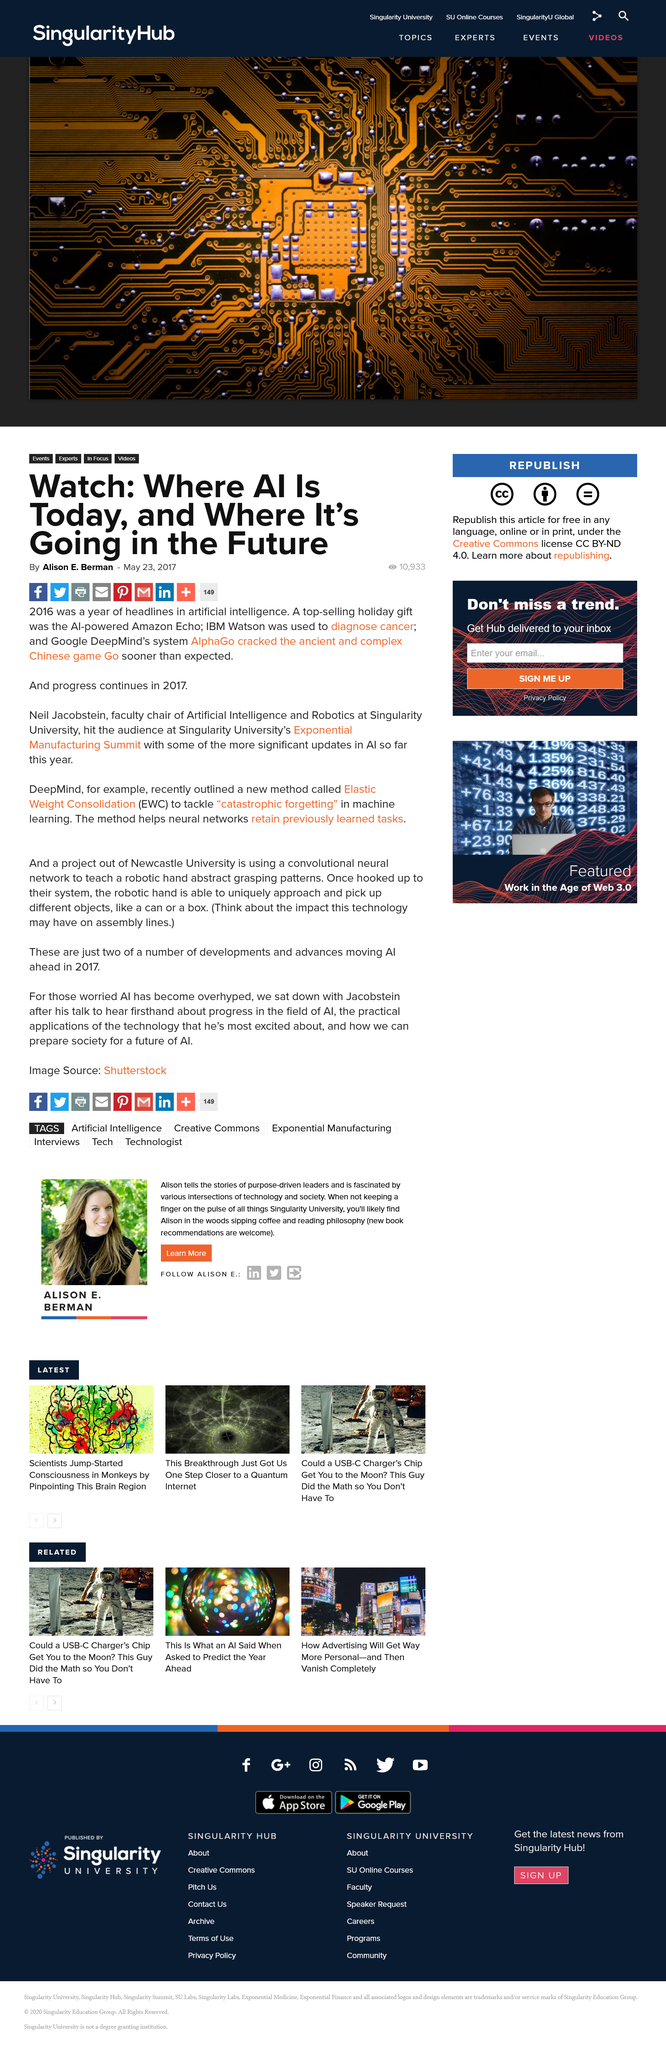Mention a couple of crucial points in this snapshot. Elastic Weight Consolidation (EWC) is a technique that involves consolidating data and resources from multiple storage systems into a single, unified environment, allowing for better management and utilization of storage resources. Google DeepMind's AlphaGo system achieved the feat of archiving the ancient and complex Chinese game of Go before its expected time, breaking the previous records. I declare that the Amazon Echo is an AI-powered top-selling gift that has been named as one. 